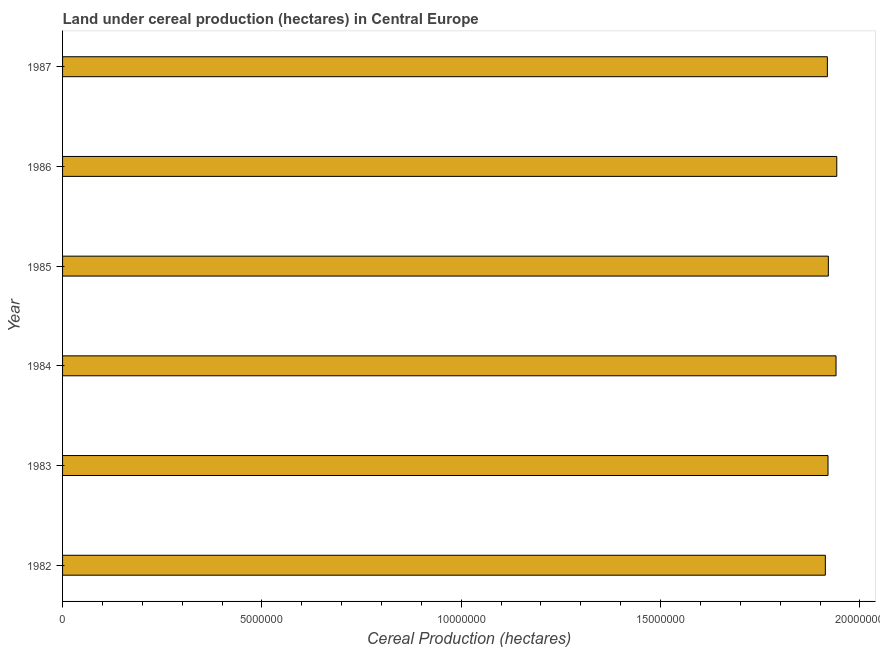Does the graph contain any zero values?
Give a very brief answer. No. Does the graph contain grids?
Your response must be concise. No. What is the title of the graph?
Provide a short and direct response. Land under cereal production (hectares) in Central Europe. What is the label or title of the X-axis?
Your response must be concise. Cereal Production (hectares). What is the land under cereal production in 1983?
Provide a short and direct response. 1.92e+07. Across all years, what is the maximum land under cereal production?
Your answer should be compact. 1.94e+07. Across all years, what is the minimum land under cereal production?
Offer a terse response. 1.91e+07. In which year was the land under cereal production maximum?
Ensure brevity in your answer.  1986. What is the sum of the land under cereal production?
Your answer should be very brief. 1.16e+08. What is the difference between the land under cereal production in 1985 and 1986?
Make the answer very short. -2.12e+05. What is the average land under cereal production per year?
Offer a very short reply. 1.93e+07. What is the median land under cereal production?
Your answer should be very brief. 1.92e+07. In how many years, is the land under cereal production greater than 1000000 hectares?
Keep it short and to the point. 6. Is the difference between the land under cereal production in 1982 and 1984 greater than the difference between any two years?
Your answer should be compact. No. What is the difference between the highest and the second highest land under cereal production?
Make the answer very short. 1.88e+04. What is the difference between the highest and the lowest land under cereal production?
Provide a short and direct response. 2.87e+05. In how many years, is the land under cereal production greater than the average land under cereal production taken over all years?
Your answer should be very brief. 2. How many bars are there?
Provide a succinct answer. 6. How many years are there in the graph?
Your response must be concise. 6. What is the Cereal Production (hectares) of 1982?
Keep it short and to the point. 1.91e+07. What is the Cereal Production (hectares) in 1983?
Give a very brief answer. 1.92e+07. What is the Cereal Production (hectares) in 1984?
Offer a very short reply. 1.94e+07. What is the Cereal Production (hectares) in 1985?
Keep it short and to the point. 1.92e+07. What is the Cereal Production (hectares) of 1986?
Your response must be concise. 1.94e+07. What is the Cereal Production (hectares) in 1987?
Ensure brevity in your answer.  1.92e+07. What is the difference between the Cereal Production (hectares) in 1982 and 1983?
Provide a short and direct response. -6.69e+04. What is the difference between the Cereal Production (hectares) in 1982 and 1984?
Give a very brief answer. -2.68e+05. What is the difference between the Cereal Production (hectares) in 1982 and 1985?
Your answer should be compact. -7.52e+04. What is the difference between the Cereal Production (hectares) in 1982 and 1986?
Provide a succinct answer. -2.87e+05. What is the difference between the Cereal Production (hectares) in 1982 and 1987?
Your answer should be compact. -5.08e+04. What is the difference between the Cereal Production (hectares) in 1983 and 1984?
Ensure brevity in your answer.  -2.01e+05. What is the difference between the Cereal Production (hectares) in 1983 and 1985?
Your response must be concise. -8326. What is the difference between the Cereal Production (hectares) in 1983 and 1986?
Make the answer very short. -2.20e+05. What is the difference between the Cereal Production (hectares) in 1983 and 1987?
Provide a succinct answer. 1.60e+04. What is the difference between the Cereal Production (hectares) in 1984 and 1985?
Make the answer very short. 1.93e+05. What is the difference between the Cereal Production (hectares) in 1984 and 1986?
Ensure brevity in your answer.  -1.88e+04. What is the difference between the Cereal Production (hectares) in 1984 and 1987?
Your answer should be compact. 2.17e+05. What is the difference between the Cereal Production (hectares) in 1985 and 1986?
Provide a succinct answer. -2.12e+05. What is the difference between the Cereal Production (hectares) in 1985 and 1987?
Your answer should be very brief. 2.44e+04. What is the difference between the Cereal Production (hectares) in 1986 and 1987?
Provide a short and direct response. 2.36e+05. What is the ratio of the Cereal Production (hectares) in 1982 to that in 1985?
Your response must be concise. 1. What is the ratio of the Cereal Production (hectares) in 1982 to that in 1987?
Make the answer very short. 1. What is the ratio of the Cereal Production (hectares) in 1983 to that in 1985?
Ensure brevity in your answer.  1. What is the ratio of the Cereal Production (hectares) in 1983 to that in 1986?
Give a very brief answer. 0.99. What is the ratio of the Cereal Production (hectares) in 1984 to that in 1986?
Offer a terse response. 1. What is the ratio of the Cereal Production (hectares) in 1984 to that in 1987?
Your answer should be compact. 1.01. What is the ratio of the Cereal Production (hectares) in 1985 to that in 1986?
Give a very brief answer. 0.99. What is the ratio of the Cereal Production (hectares) in 1985 to that in 1987?
Your response must be concise. 1. 